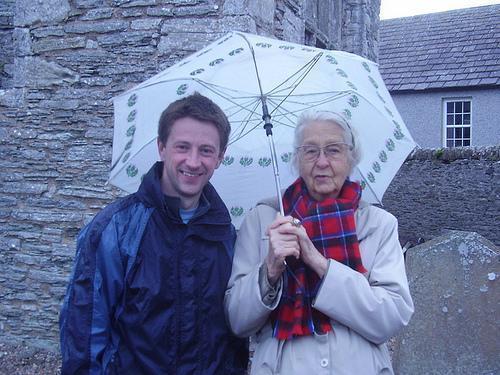How many people are wearing glasses?
Give a very brief answer. 1. How many people are in this photo?
Give a very brief answer. 2. 